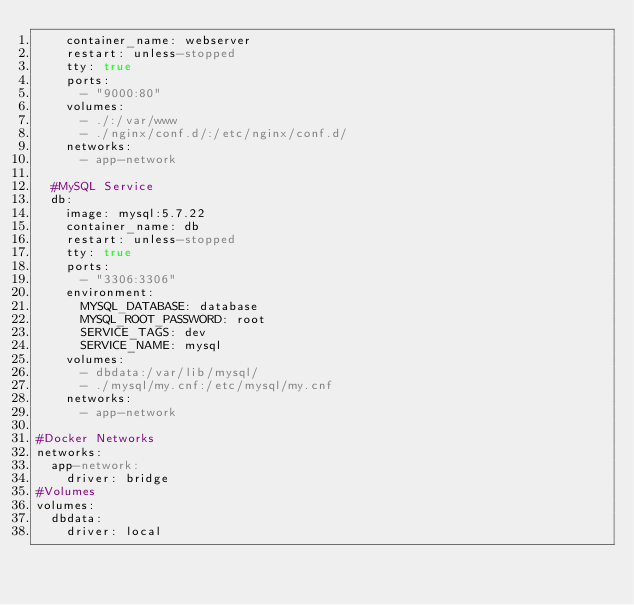Convert code to text. <code><loc_0><loc_0><loc_500><loc_500><_YAML_>    container_name: webserver
    restart: unless-stopped
    tty: true
    ports:
      - "9000:80"
    volumes:
      - ./:/var/www
      - ./nginx/conf.d/:/etc/nginx/conf.d/
    networks:
      - app-network

  #MySQL Service
  db:
    image: mysql:5.7.22
    container_name: db
    restart: unless-stopped
    tty: true
    ports:
      - "3306:3306"
    environment:
      MYSQL_DATABASE: database
      MYSQL_ROOT_PASSWORD: root
      SERVICE_TAGS: dev
      SERVICE_NAME: mysql
    volumes:
      - dbdata:/var/lib/mysql/
      - ./mysql/my.cnf:/etc/mysql/my.cnf
    networks:
      - app-network

#Docker Networks
networks:
  app-network:
    driver: bridge
#Volumes
volumes:
  dbdata:
    driver: local</code> 